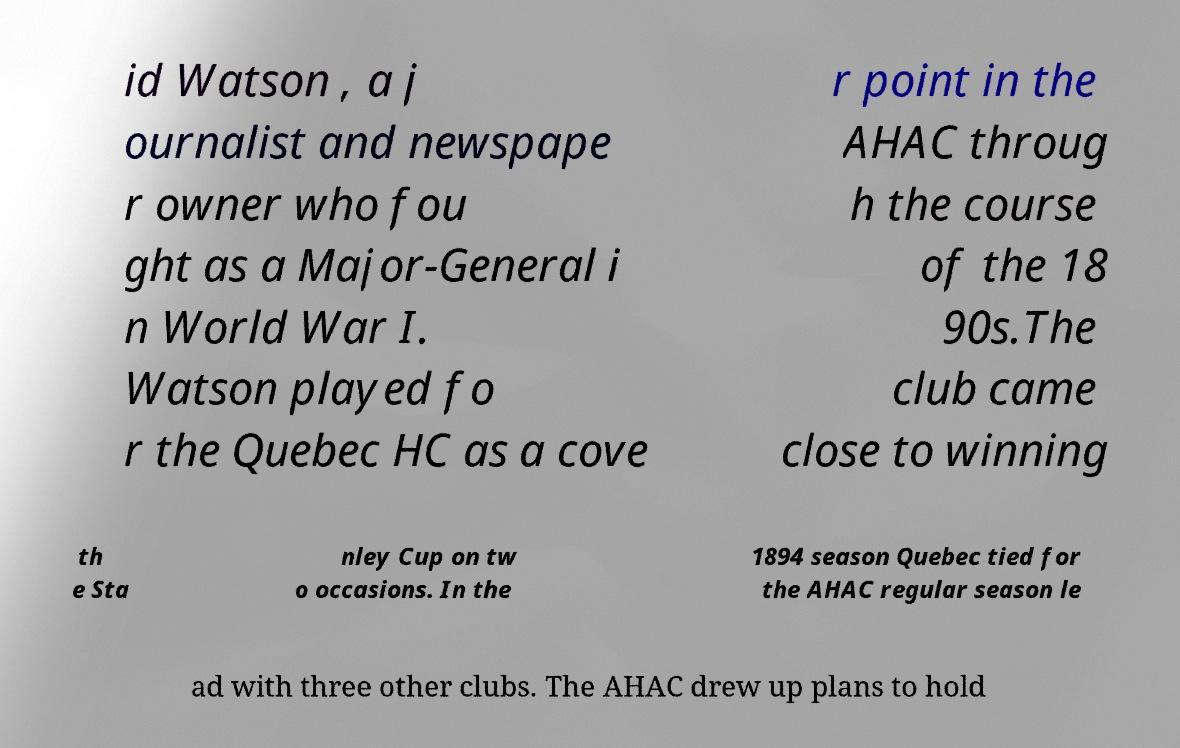There's text embedded in this image that I need extracted. Can you transcribe it verbatim? id Watson , a j ournalist and newspape r owner who fou ght as a Major-General i n World War I. Watson played fo r the Quebec HC as a cove r point in the AHAC throug h the course of the 18 90s.The club came close to winning th e Sta nley Cup on tw o occasions. In the 1894 season Quebec tied for the AHAC regular season le ad with three other clubs. The AHAC drew up plans to hold 